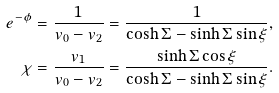<formula> <loc_0><loc_0><loc_500><loc_500>e ^ { - \phi } & = \frac { 1 } { v _ { 0 } - v _ { 2 } } = \frac { 1 } { \cosh \Sigma - \sinh \Sigma \sin \xi } , \\ \chi & = \frac { v _ { 1 } } { v _ { 0 } - v _ { 2 } } = \frac { \sinh \Sigma \cos \xi } { \cosh \Sigma - \sinh \Sigma \sin \xi } .</formula> 